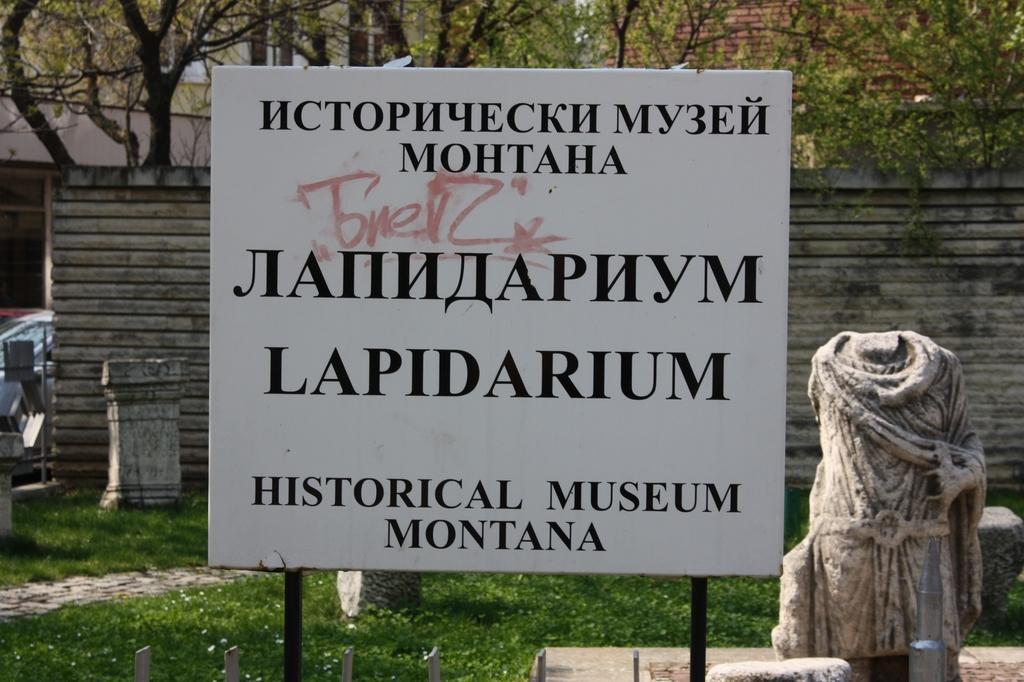Could you give a brief overview of what you see in this image? In this image there vehicles on the left corner. There is a board with text in the foreground. There is a statue on the right corner. There is grass at the bottom. There are trees, buildings and a wall in the background. 